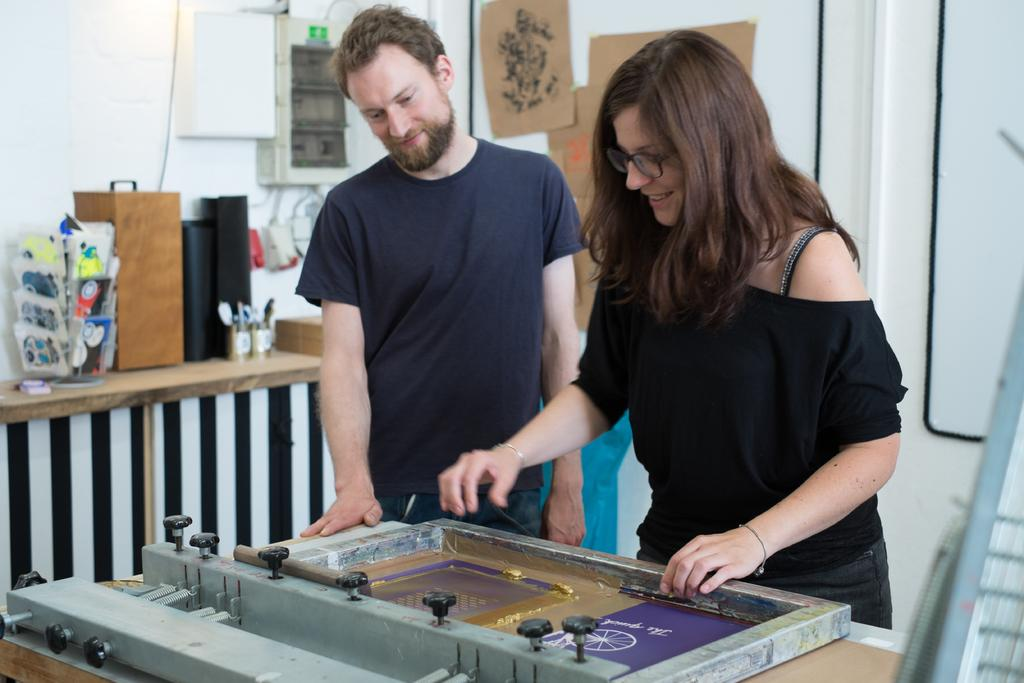Who is present in the image? There is a couple in the image. What are the couple doing in the image? The couple is playing a board game. What else can be seen in the image besides the couple and the board game? There are articles on a table beside the couple. What type of bone can be seen in the image? There is no bone present in the image. What color is the gold object in the image? There is no gold object present in the image. 